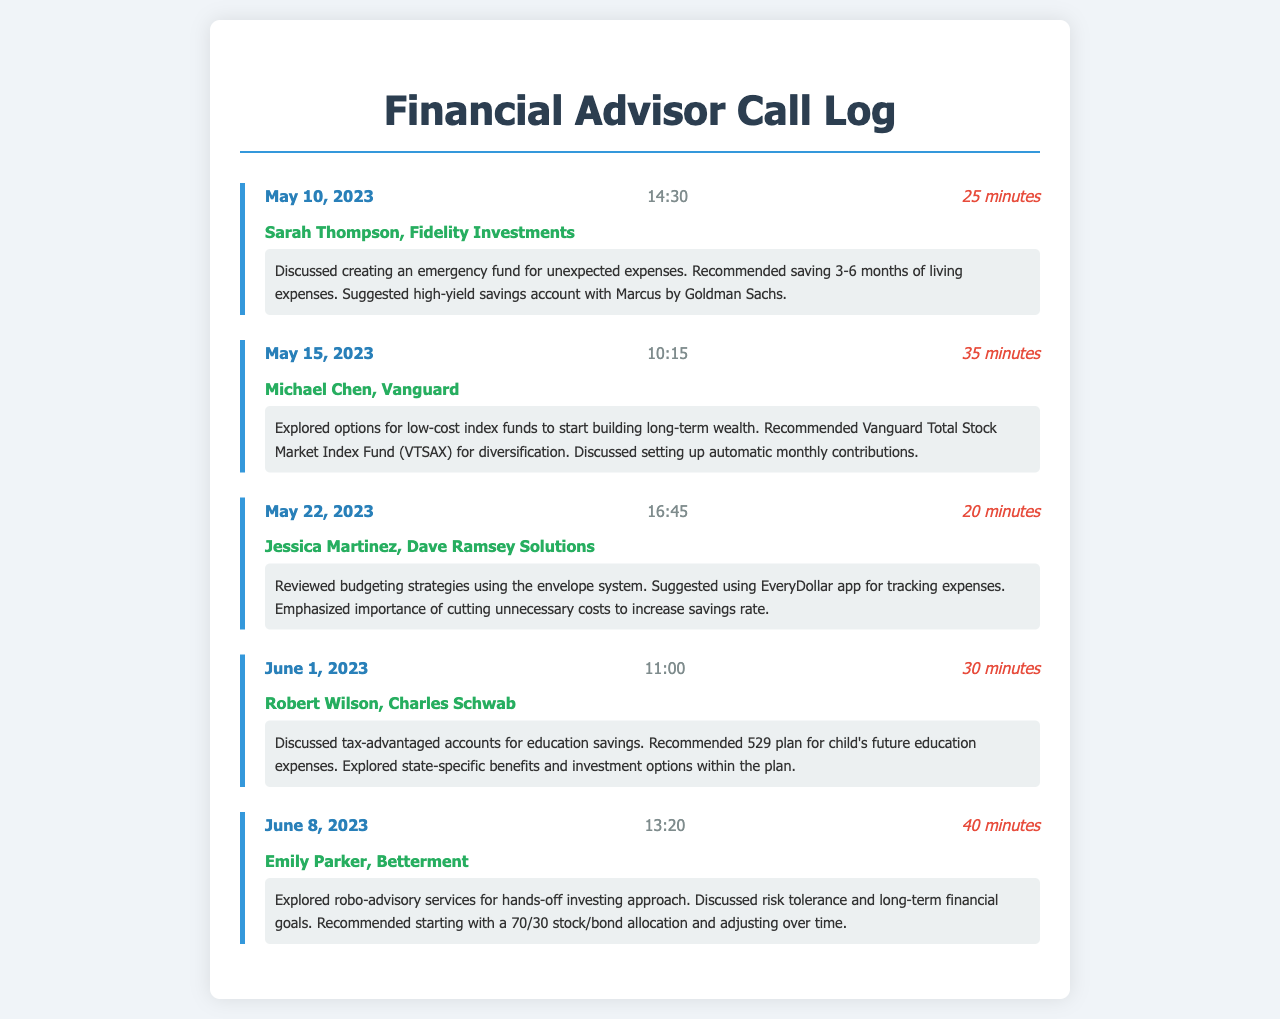what date did the call with Sarah Thompson occur? The document lists the date of the call with Sarah Thompson, which is May 10, 2023.
Answer: May 10, 2023 who was the advisor during the call on May 15, 2023? The advisor for the call on May 15, 2023, was Michael Chen from Vanguard.
Answer: Michael Chen, Vanguard how long was the call on June 1, 2023? The duration of the call on June 1, 2023, is explicitly mentioned in the log as 30 minutes.
Answer: 30 minutes what financial product was recommended during the call with Robert Wilson? The call with Robert Wilson discussed a specific financial product, which is the 529 plan for education savings.
Answer: 529 plan which app was suggested for budgeting strategies? The EveryDollar app was mentioned in the context of discussing budgeting strategies during the call with Jessica Martinez.
Answer: EveryDollar app how many minutes was the longest call recorded? The longest call recorded in the document was 40 minutes during the call with Emily Parker.
Answer: 40 minutes what was the main topic discussed in the call with Jessica Martinez? The main topic discussed with Jessica Martinez focused on budgeting strategies using the envelope system.
Answer: Budgeting strategies which advisor recommended automatic monthly contributions? Michael Chen recommended setting up automatic monthly contributions during the call.
Answer: Michael Chen what is the proposed savings for an emergency fund? The recommended amount for an emergency fund discussed with Sarah Thompson is 3-6 months of living expenses.
Answer: 3-6 months of living expenses 